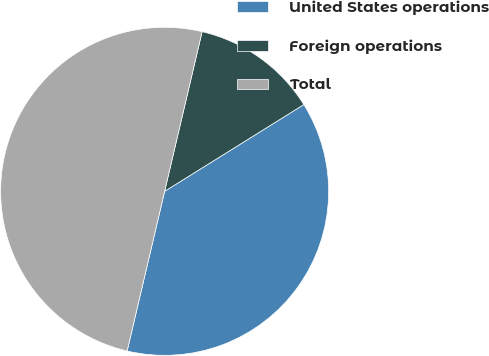Convert chart. <chart><loc_0><loc_0><loc_500><loc_500><pie_chart><fcel>United States operations<fcel>Foreign operations<fcel>Total<nl><fcel>37.54%<fcel>12.46%<fcel>50.0%<nl></chart> 